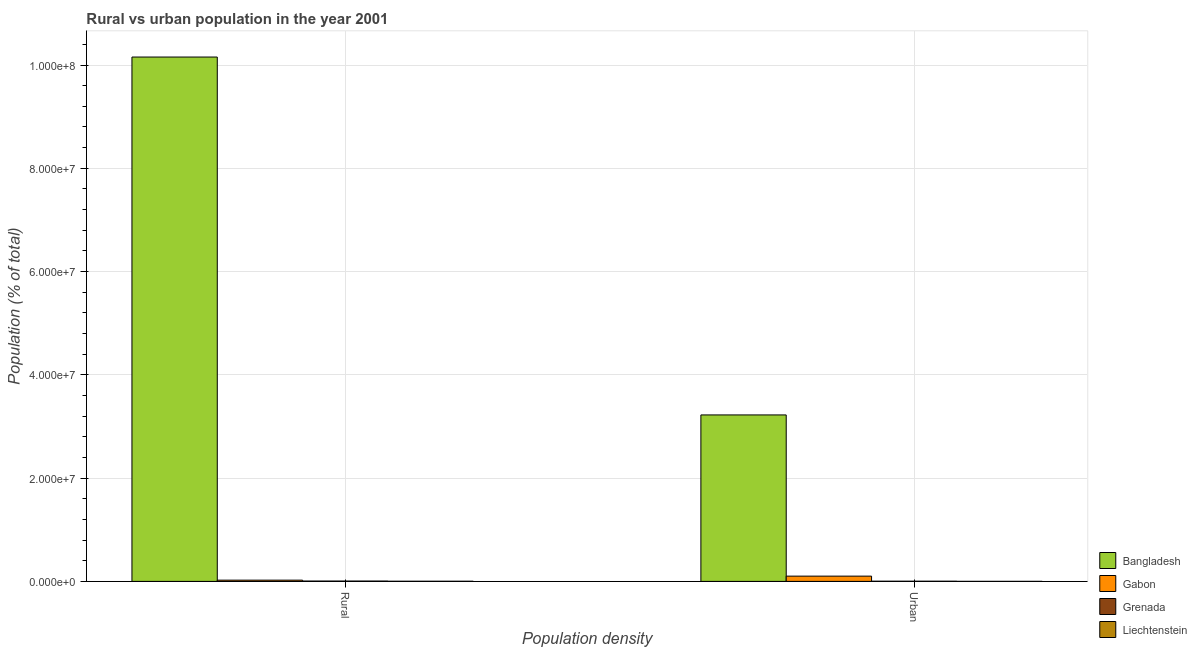What is the label of the 1st group of bars from the left?
Offer a very short reply. Rural. What is the urban population density in Bangladesh?
Provide a short and direct response. 3.22e+07. Across all countries, what is the maximum urban population density?
Your answer should be compact. 3.22e+07. Across all countries, what is the minimum rural population density?
Provide a short and direct response. 2.86e+04. In which country was the rural population density minimum?
Your answer should be very brief. Liechtenstein. What is the total urban population density in the graph?
Make the answer very short. 3.33e+07. What is the difference between the urban population density in Grenada and that in Liechtenstein?
Offer a very short reply. 3.17e+04. What is the difference between the urban population density in Liechtenstein and the rural population density in Grenada?
Keep it short and to the point. -6.00e+04. What is the average urban population density per country?
Your response must be concise. 8.32e+06. What is the difference between the rural population density and urban population density in Liechtenstein?
Offer a terse response. 2.36e+04. What is the ratio of the urban population density in Gabon to that in Bangladesh?
Ensure brevity in your answer.  0.03. Is the rural population density in Liechtenstein less than that in Grenada?
Provide a succinct answer. Yes. In how many countries, is the urban population density greater than the average urban population density taken over all countries?
Make the answer very short. 1. What does the 2nd bar from the left in Urban represents?
Offer a terse response. Gabon. What does the 3rd bar from the right in Rural represents?
Provide a short and direct response. Gabon. Are all the bars in the graph horizontal?
Your answer should be compact. No. What is the difference between two consecutive major ticks on the Y-axis?
Offer a very short reply. 2.00e+07. Are the values on the major ticks of Y-axis written in scientific E-notation?
Provide a succinct answer. Yes. Does the graph contain grids?
Ensure brevity in your answer.  Yes. How many legend labels are there?
Your answer should be very brief. 4. What is the title of the graph?
Provide a short and direct response. Rural vs urban population in the year 2001. Does "Europe(all income levels)" appear as one of the legend labels in the graph?
Your answer should be very brief. No. What is the label or title of the X-axis?
Your answer should be very brief. Population density. What is the label or title of the Y-axis?
Keep it short and to the point. Population (% of total). What is the Population (% of total) in Bangladesh in Rural?
Offer a terse response. 1.02e+08. What is the Population (% of total) in Gabon in Rural?
Offer a terse response. 2.41e+05. What is the Population (% of total) of Grenada in Rural?
Offer a terse response. 6.51e+04. What is the Population (% of total) of Liechtenstein in Rural?
Provide a succinct answer. 2.86e+04. What is the Population (% of total) in Bangladesh in Urban?
Provide a succinct answer. 3.22e+07. What is the Population (% of total) in Gabon in Urban?
Provide a short and direct response. 1.02e+06. What is the Population (% of total) in Grenada in Urban?
Your answer should be very brief. 3.68e+04. What is the Population (% of total) in Liechtenstein in Urban?
Your answer should be compact. 5037. Across all Population density, what is the maximum Population (% of total) of Bangladesh?
Offer a terse response. 1.02e+08. Across all Population density, what is the maximum Population (% of total) of Gabon?
Your answer should be compact. 1.02e+06. Across all Population density, what is the maximum Population (% of total) of Grenada?
Offer a terse response. 6.51e+04. Across all Population density, what is the maximum Population (% of total) in Liechtenstein?
Provide a succinct answer. 2.86e+04. Across all Population density, what is the minimum Population (% of total) in Bangladesh?
Give a very brief answer. 3.22e+07. Across all Population density, what is the minimum Population (% of total) in Gabon?
Your response must be concise. 2.41e+05. Across all Population density, what is the minimum Population (% of total) in Grenada?
Your response must be concise. 3.68e+04. Across all Population density, what is the minimum Population (% of total) in Liechtenstein?
Provide a succinct answer. 5037. What is the total Population (% of total) in Bangladesh in the graph?
Provide a succinct answer. 1.34e+08. What is the total Population (% of total) of Gabon in the graph?
Offer a terse response. 1.26e+06. What is the total Population (% of total) of Grenada in the graph?
Give a very brief answer. 1.02e+05. What is the total Population (% of total) in Liechtenstein in the graph?
Your answer should be compact. 3.37e+04. What is the difference between the Population (% of total) in Bangladesh in Rural and that in Urban?
Make the answer very short. 6.93e+07. What is the difference between the Population (% of total) of Gabon in Rural and that in Urban?
Provide a short and direct response. -7.78e+05. What is the difference between the Population (% of total) of Grenada in Rural and that in Urban?
Your response must be concise. 2.83e+04. What is the difference between the Population (% of total) in Liechtenstein in Rural and that in Urban?
Provide a succinct answer. 2.36e+04. What is the difference between the Population (% of total) in Bangladesh in Rural and the Population (% of total) in Gabon in Urban?
Keep it short and to the point. 1.01e+08. What is the difference between the Population (% of total) in Bangladesh in Rural and the Population (% of total) in Grenada in Urban?
Provide a succinct answer. 1.02e+08. What is the difference between the Population (% of total) of Bangladesh in Rural and the Population (% of total) of Liechtenstein in Urban?
Your response must be concise. 1.02e+08. What is the difference between the Population (% of total) in Gabon in Rural and the Population (% of total) in Grenada in Urban?
Give a very brief answer. 2.05e+05. What is the difference between the Population (% of total) in Gabon in Rural and the Population (% of total) in Liechtenstein in Urban?
Your answer should be compact. 2.36e+05. What is the difference between the Population (% of total) of Grenada in Rural and the Population (% of total) of Liechtenstein in Urban?
Provide a short and direct response. 6.00e+04. What is the average Population (% of total) of Bangladesh per Population density?
Your answer should be compact. 6.69e+07. What is the average Population (% of total) of Gabon per Population density?
Ensure brevity in your answer.  6.30e+05. What is the average Population (% of total) of Grenada per Population density?
Ensure brevity in your answer.  5.09e+04. What is the average Population (% of total) of Liechtenstein per Population density?
Offer a very short reply. 1.68e+04. What is the difference between the Population (% of total) in Bangladesh and Population (% of total) in Gabon in Rural?
Your answer should be very brief. 1.01e+08. What is the difference between the Population (% of total) in Bangladesh and Population (% of total) in Grenada in Rural?
Make the answer very short. 1.01e+08. What is the difference between the Population (% of total) in Bangladesh and Population (% of total) in Liechtenstein in Rural?
Offer a very short reply. 1.02e+08. What is the difference between the Population (% of total) in Gabon and Population (% of total) in Grenada in Rural?
Provide a short and direct response. 1.76e+05. What is the difference between the Population (% of total) in Gabon and Population (% of total) in Liechtenstein in Rural?
Ensure brevity in your answer.  2.13e+05. What is the difference between the Population (% of total) of Grenada and Population (% of total) of Liechtenstein in Rural?
Make the answer very short. 3.64e+04. What is the difference between the Population (% of total) of Bangladesh and Population (% of total) of Gabon in Urban?
Your answer should be compact. 3.12e+07. What is the difference between the Population (% of total) of Bangladesh and Population (% of total) of Grenada in Urban?
Make the answer very short. 3.22e+07. What is the difference between the Population (% of total) in Bangladesh and Population (% of total) in Liechtenstein in Urban?
Provide a succinct answer. 3.22e+07. What is the difference between the Population (% of total) of Gabon and Population (% of total) of Grenada in Urban?
Make the answer very short. 9.82e+05. What is the difference between the Population (% of total) of Gabon and Population (% of total) of Liechtenstein in Urban?
Make the answer very short. 1.01e+06. What is the difference between the Population (% of total) of Grenada and Population (% of total) of Liechtenstein in Urban?
Your answer should be very brief. 3.17e+04. What is the ratio of the Population (% of total) of Bangladesh in Rural to that in Urban?
Ensure brevity in your answer.  3.15. What is the ratio of the Population (% of total) in Gabon in Rural to that in Urban?
Offer a very short reply. 0.24. What is the ratio of the Population (% of total) of Grenada in Rural to that in Urban?
Your answer should be very brief. 1.77. What is the ratio of the Population (% of total) in Liechtenstein in Rural to that in Urban?
Your response must be concise. 5.68. What is the difference between the highest and the second highest Population (% of total) of Bangladesh?
Give a very brief answer. 6.93e+07. What is the difference between the highest and the second highest Population (% of total) in Gabon?
Offer a very short reply. 7.78e+05. What is the difference between the highest and the second highest Population (% of total) in Grenada?
Your answer should be compact. 2.83e+04. What is the difference between the highest and the second highest Population (% of total) in Liechtenstein?
Your response must be concise. 2.36e+04. What is the difference between the highest and the lowest Population (% of total) in Bangladesh?
Your response must be concise. 6.93e+07. What is the difference between the highest and the lowest Population (% of total) in Gabon?
Your response must be concise. 7.78e+05. What is the difference between the highest and the lowest Population (% of total) of Grenada?
Make the answer very short. 2.83e+04. What is the difference between the highest and the lowest Population (% of total) of Liechtenstein?
Offer a very short reply. 2.36e+04. 